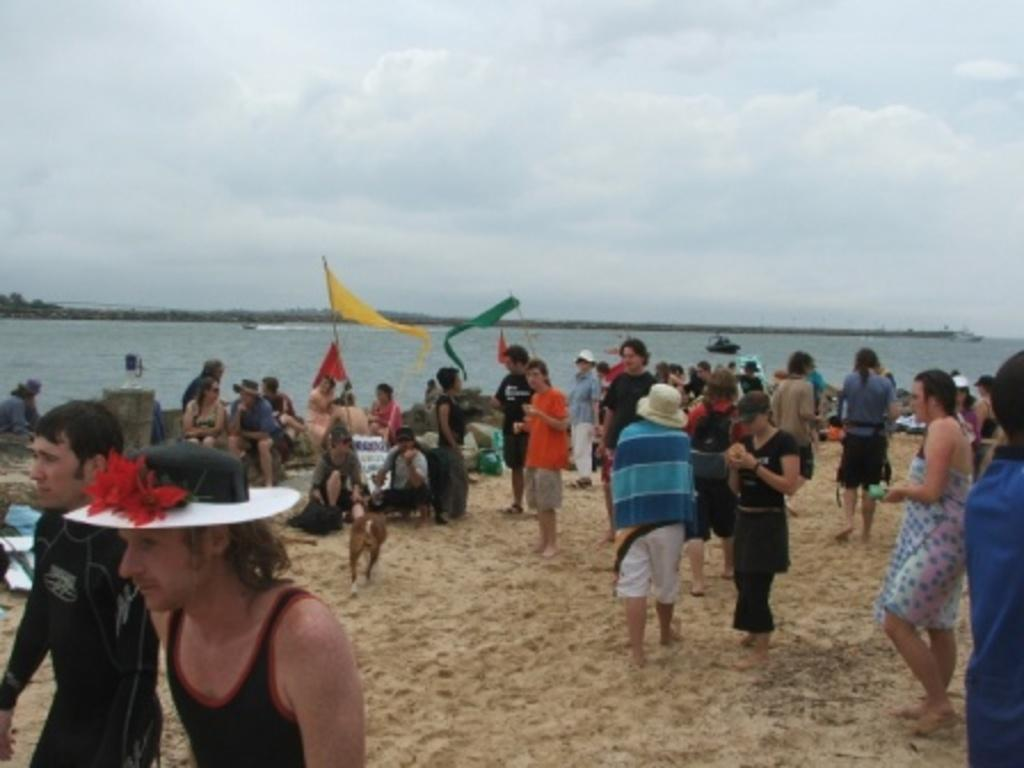How many people are in the image? There are people in the image, but the exact number is not specified. What can be observed about the people's clothing? The people are wearing different color dresses. What can be seen in the background of the image? There are colorful flags, water, a dog, and trees in the background. What is the color of the sky in the image? The sky appears to be white in color. What type of crook can be seen holding a tin of marbles in the image? There is no crook, tin, or marbles present in the image. 